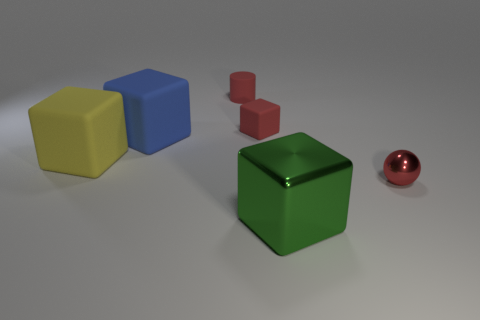Subtract all large yellow matte blocks. How many blocks are left? 3 Subtract 1 cylinders. How many cylinders are left? 0 Subtract all cyan blocks. Subtract all blue cylinders. How many blocks are left? 4 Subtract all gray cylinders. How many green cubes are left? 1 Subtract all large yellow matte cubes. Subtract all large blue things. How many objects are left? 4 Add 4 big cubes. How many big cubes are left? 7 Add 5 big metal cubes. How many big metal cubes exist? 6 Add 2 tiny cylinders. How many objects exist? 8 Subtract all red cubes. How many cubes are left? 3 Subtract 1 red cubes. How many objects are left? 5 